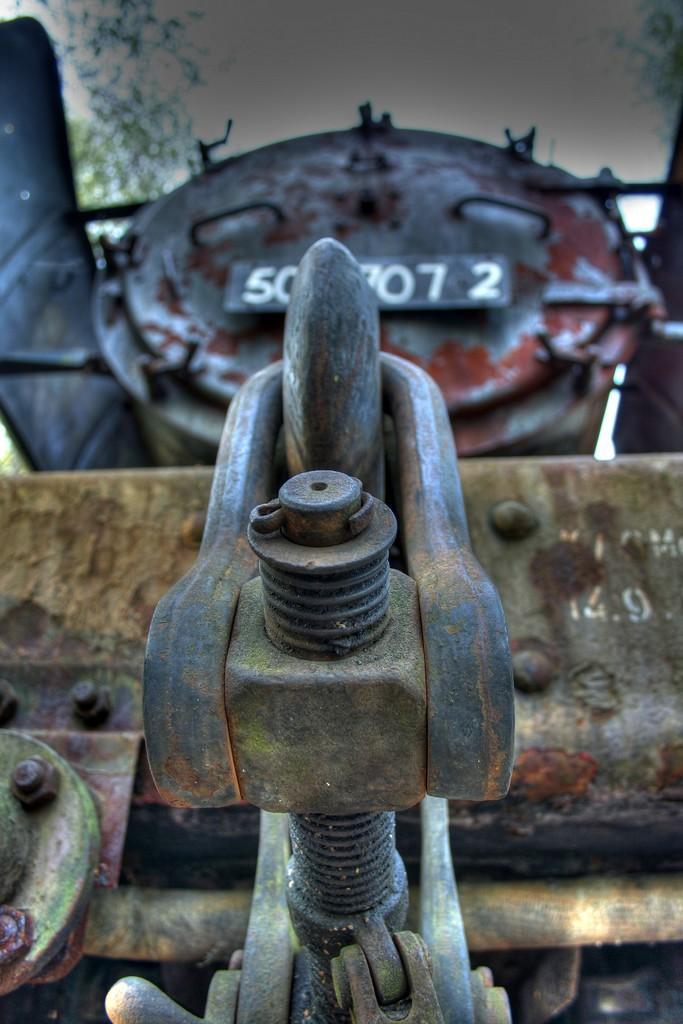Please provide a concise description of this image. In this image there is a train facing forward. Front side of image there is a nut and bolt. Behind the train there are few trees and sky. 